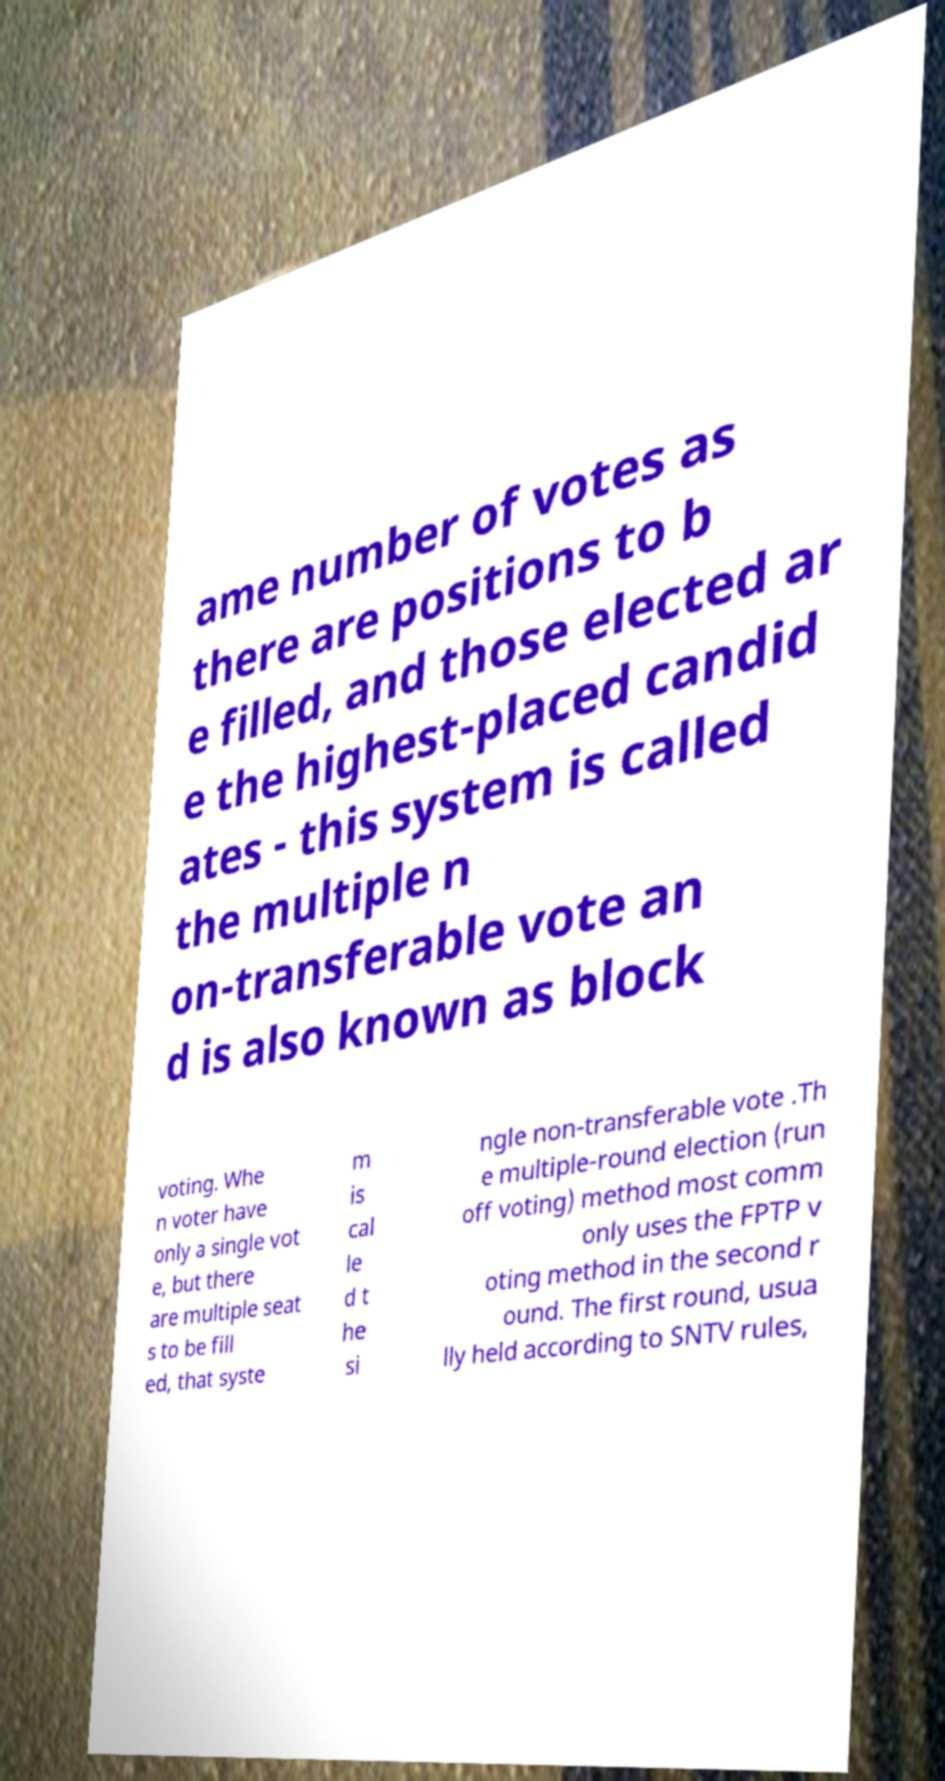What messages or text are displayed in this image? I need them in a readable, typed format. ame number of votes as there are positions to b e filled, and those elected ar e the highest-placed candid ates - this system is called the multiple n on-transferable vote an d is also known as block voting. Whe n voter have only a single vot e, but there are multiple seat s to be fill ed, that syste m is cal le d t he si ngle non-transferable vote .Th e multiple-round election (run off voting) method most comm only uses the FPTP v oting method in the second r ound. The first round, usua lly held according to SNTV rules, 